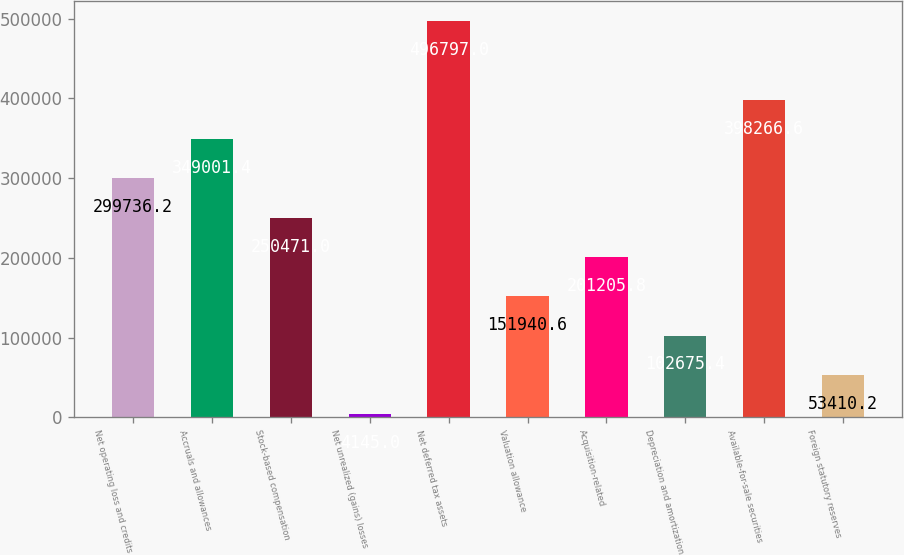<chart> <loc_0><loc_0><loc_500><loc_500><bar_chart><fcel>Net operating loss and credits<fcel>Accruals and allowances<fcel>Stock-based compensation<fcel>Net unrealized (gains) losses<fcel>Net deferred tax assets<fcel>Valuation allowance<fcel>Acquisition-related<fcel>Depreciation and amortization<fcel>Available-for-sale securities<fcel>Foreign statutory reserves<nl><fcel>299736<fcel>349001<fcel>250471<fcel>4145<fcel>496797<fcel>151941<fcel>201206<fcel>102675<fcel>398267<fcel>53410.2<nl></chart> 